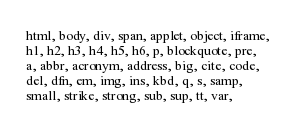<code> <loc_0><loc_0><loc_500><loc_500><_CSS_>html, body, div, span, applet, object, iframe,
h1, h2, h3, h4, h5, h6, p, blockquote, pre,
a, abbr, acronym, address, big, cite, code,
del, dfn, em, img, ins, kbd, q, s, samp,
small, strike, strong, sub, sup, tt, var,</code> 